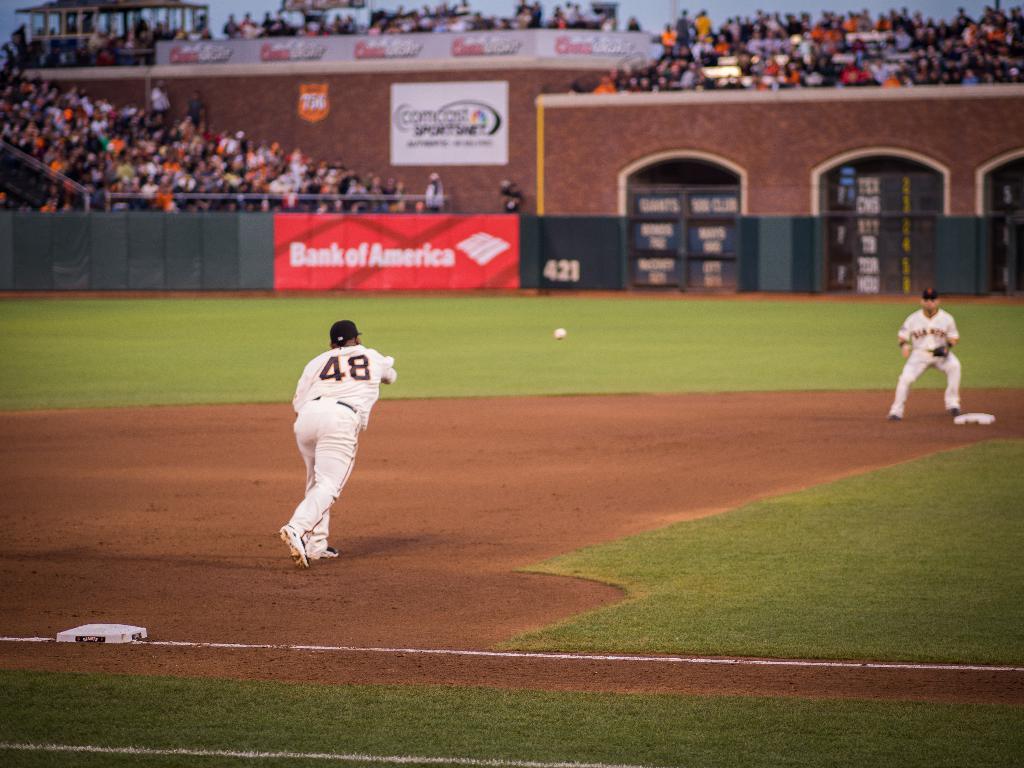What is the pitcher's number?
Ensure brevity in your answer.  48. 